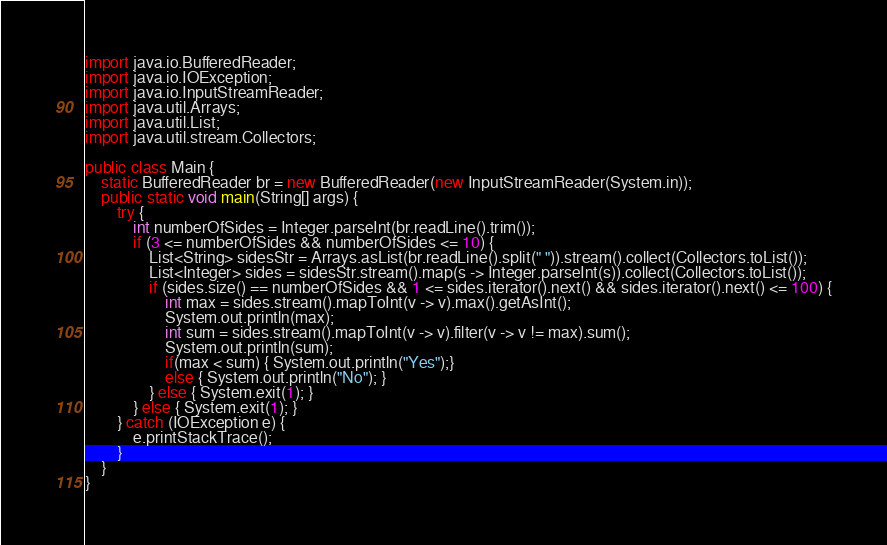Convert code to text. <code><loc_0><loc_0><loc_500><loc_500><_Java_>import java.io.BufferedReader;
import java.io.IOException;
import java.io.InputStreamReader;
import java.util.Arrays;
import java.util.List;
import java.util.stream.Collectors;

public class Main {
	static BufferedReader br = new BufferedReader(new InputStreamReader(System.in));
	public static void main(String[] args) {
	    try {
            int numberOfSides = Integer.parseInt(br.readLine().trim());
            if (3 <= numberOfSides && numberOfSides <= 10) {
            	List<String> sidesStr = Arrays.asList(br.readLine().split(" ")).stream().collect(Collectors.toList());
            	List<Integer> sides = sidesStr.stream().map(s -> Integer.parseInt(s)).collect(Collectors.toList());
            	if (sides.size() == numberOfSides && 1 <= sides.iterator().next() && sides.iterator().next() <= 100) {
                    int max = sides.stream().mapToInt(v -> v).max().getAsInt();
                    System.out.println(max);
                    int sum = sides.stream().mapToInt(v -> v).filter(v -> v != max).sum();
                    System.out.println(sum);
                    if(max < sum) { System.out.println("Yes");}
                    else { System.out.println("No"); }
            	} else { System.exit(1); }
            } else { System.exit(1); }
		} catch (IOException e) {
			e.printStackTrace();
		}
	}
}</code> 